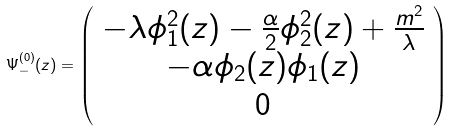Convert formula to latex. <formula><loc_0><loc_0><loc_500><loc_500>\Psi _ { - } ^ { ( 0 ) } ( z ) = \left ( \begin{array} { c c c } - \lambda \phi _ { 1 } ^ { 2 } ( z ) - \frac { \alpha } { 2 } \phi _ { 2 } ^ { 2 } ( z ) + \frac { m ^ { 2 } } { \lambda } \\ - \alpha \phi _ { 2 } ( z ) \phi _ { 1 } ( z ) \\ 0 \end{array} \right )</formula> 